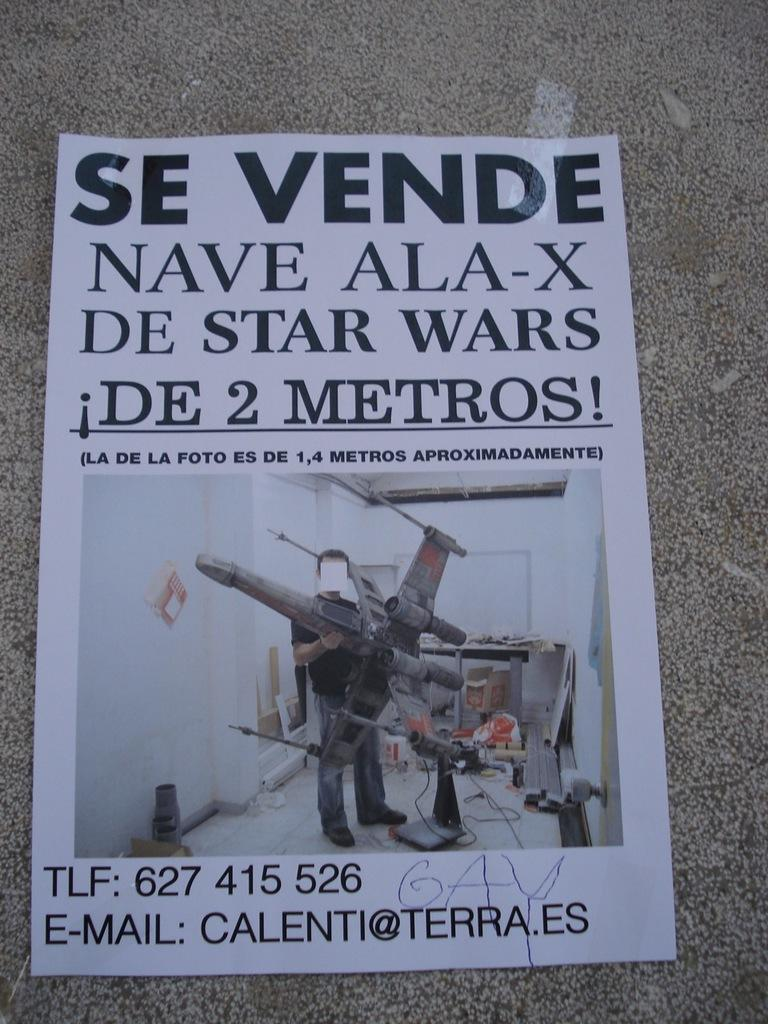<image>
Create a compact narrative representing the image presented. A printed flyer with Spanish writing and a picture of a man holding a large model airplane and contact information including the phone number and email address CALENTI@TERRA.ES. 